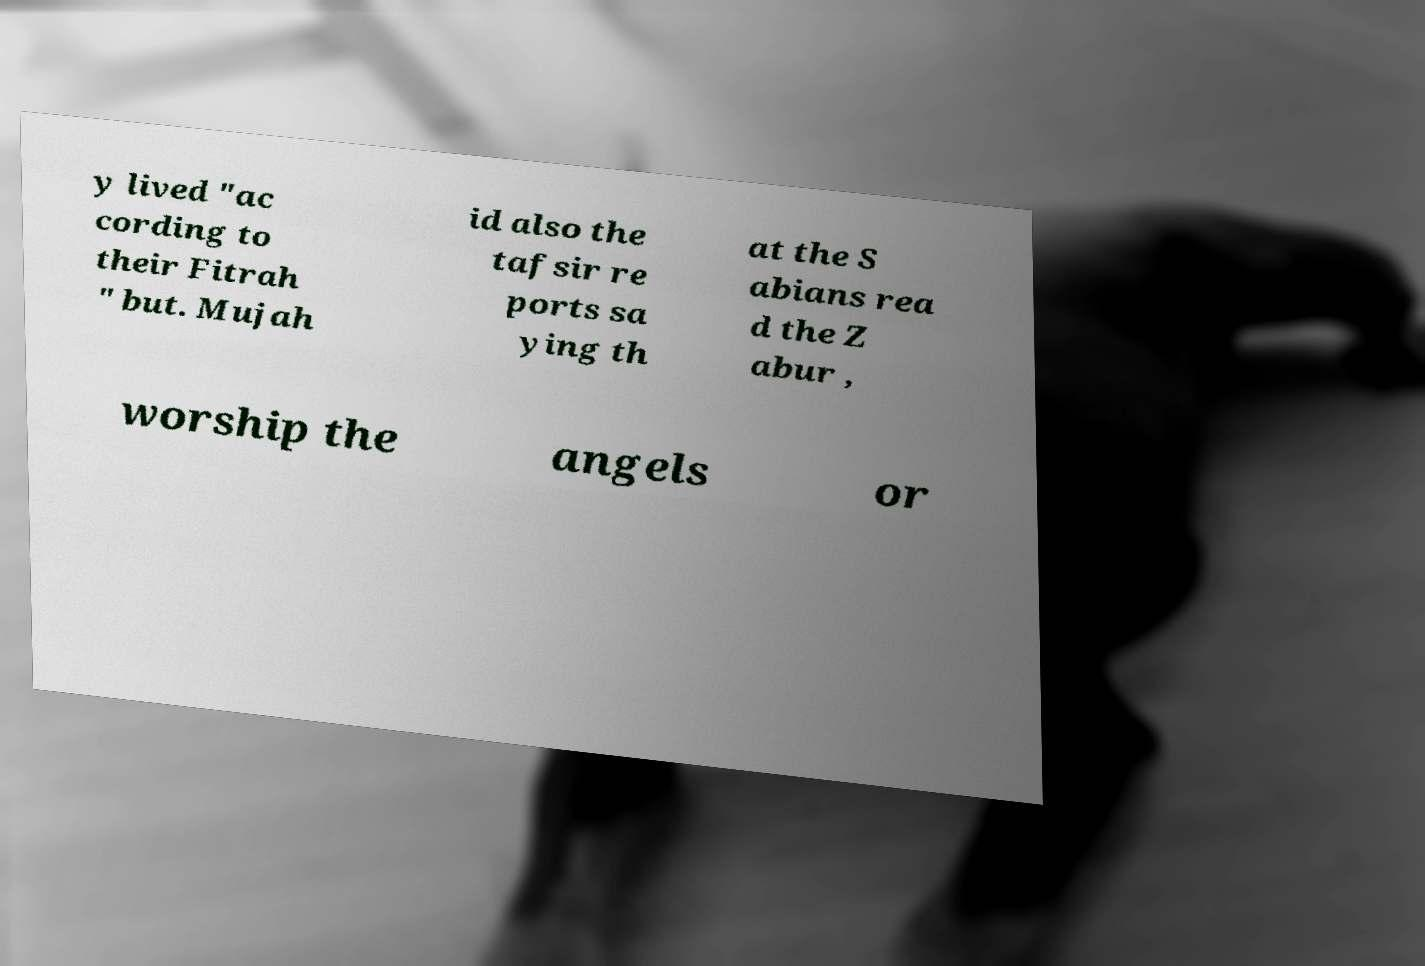Please identify and transcribe the text found in this image. y lived "ac cording to their Fitrah " but. Mujah id also the tafsir re ports sa ying th at the S abians rea d the Z abur , worship the angels or 